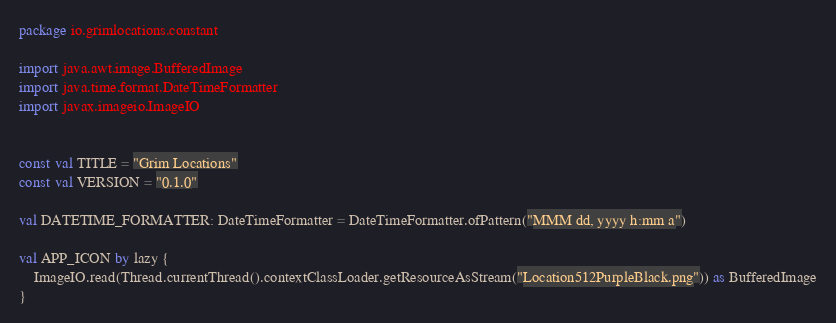Convert code to text. <code><loc_0><loc_0><loc_500><loc_500><_Kotlin_>package io.grimlocations.constant

import java.awt.image.BufferedImage
import java.time.format.DateTimeFormatter
import javax.imageio.ImageIO


const val TITLE = "Grim Locations"
const val VERSION = "0.1.0"

val DATETIME_FORMATTER: DateTimeFormatter = DateTimeFormatter.ofPattern("MMM dd, yyyy h:mm a")

val APP_ICON by lazy {
    ImageIO.read(Thread.currentThread().contextClassLoader.getResourceAsStream("Location512PurpleBlack.png")) as BufferedImage
}</code> 